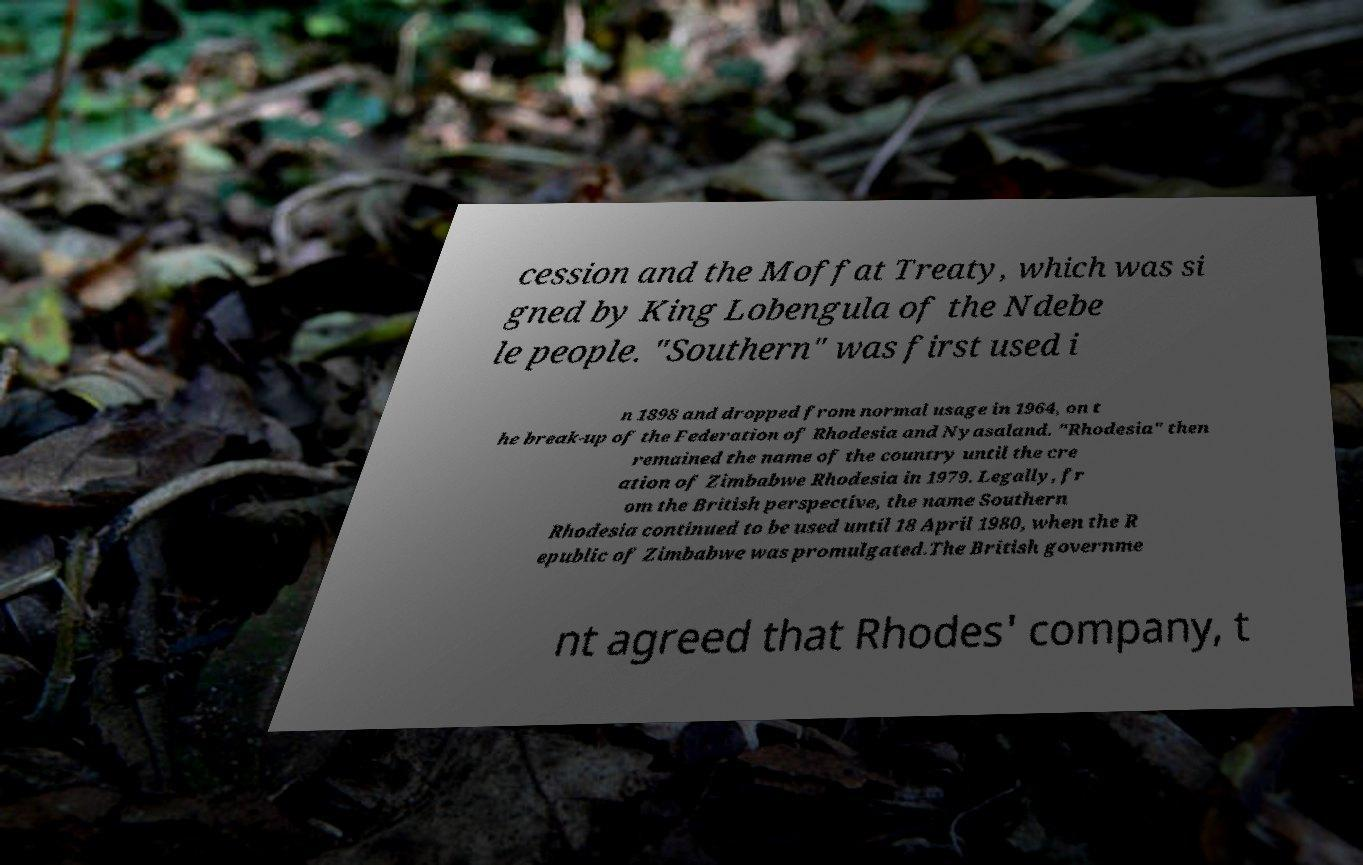Can you accurately transcribe the text from the provided image for me? cession and the Moffat Treaty, which was si gned by King Lobengula of the Ndebe le people. "Southern" was first used i n 1898 and dropped from normal usage in 1964, on t he break-up of the Federation of Rhodesia and Nyasaland. "Rhodesia" then remained the name of the country until the cre ation of Zimbabwe Rhodesia in 1979. Legally, fr om the British perspective, the name Southern Rhodesia continued to be used until 18 April 1980, when the R epublic of Zimbabwe was promulgated.The British governme nt agreed that Rhodes' company, t 